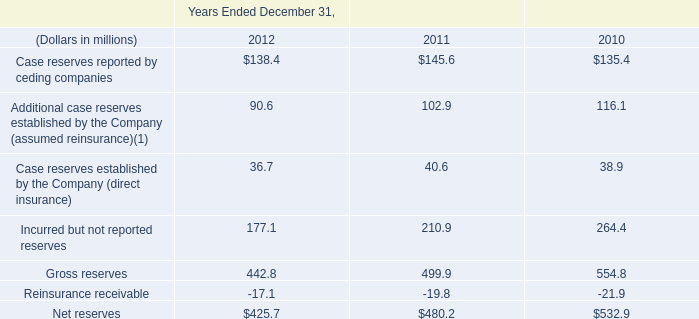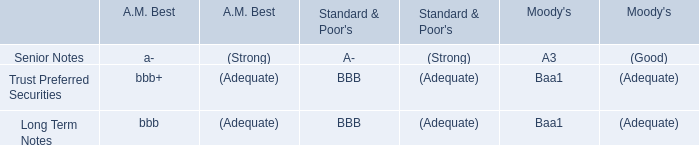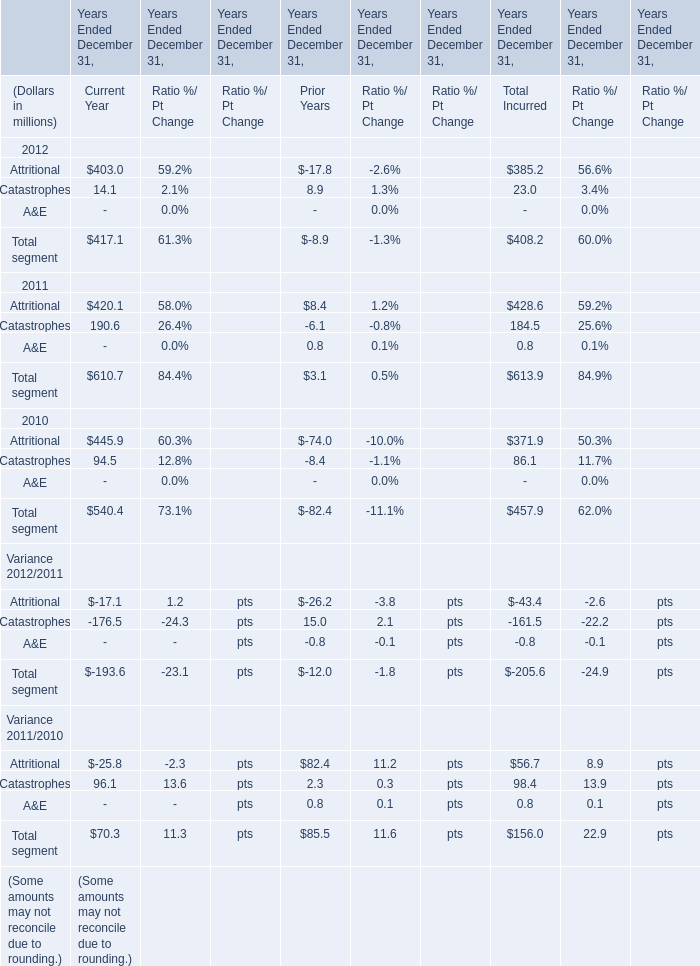What's the total amount of the prior years in the years where Catastrophes for current year is greater than 100? (in million) 
Computations: ((8.4 - 6.1) + 0.8)
Answer: 3.1. 